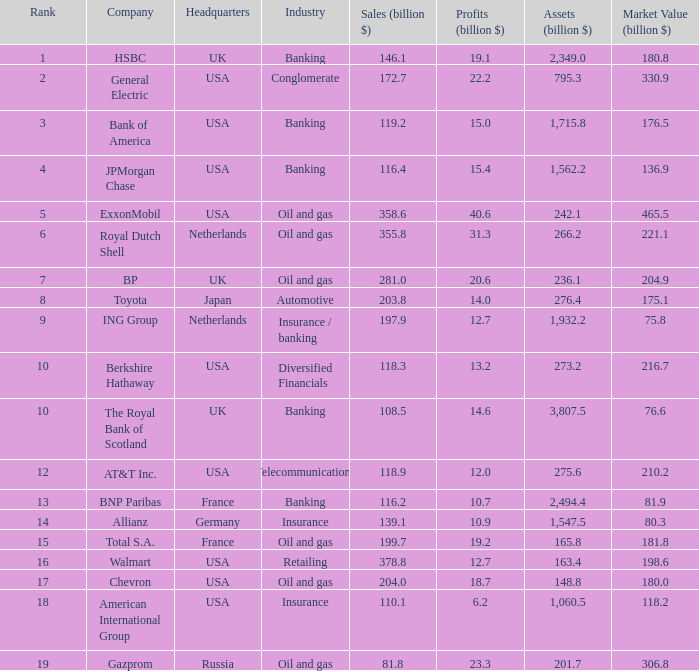What are the profits in billions for Berkshire Hathaway?  13.2. 